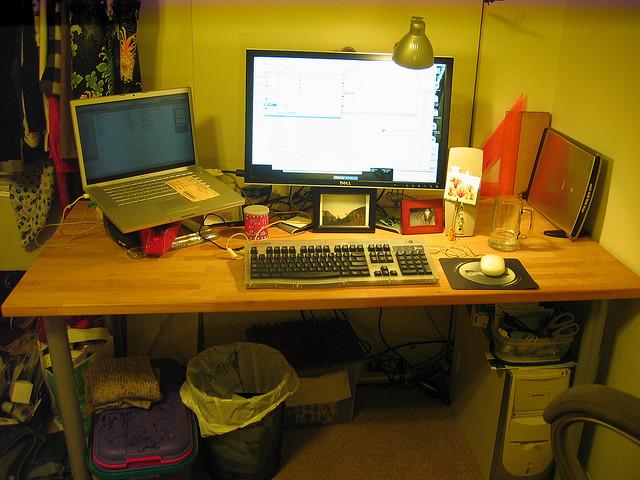Is this office nice?
Write a very short answer. No. How many computers can you see?
Quick response, please. 2. Where is the computer tower?
Give a very brief answer. Under table. What setting is shown on the screen of the laptop?
Keep it brief. Windows. How many waste cans are there?
Concise answer only. 1. Is there a bag in the trash can?
Short answer required. Yes. Does this person have a screensaver?
Be succinct. No. Is the desk lamp turned on?
Answer briefly. Yes. What color is the wall painted?
Give a very brief answer. Yellow. What color is the computer mouse?
Give a very brief answer. White. 